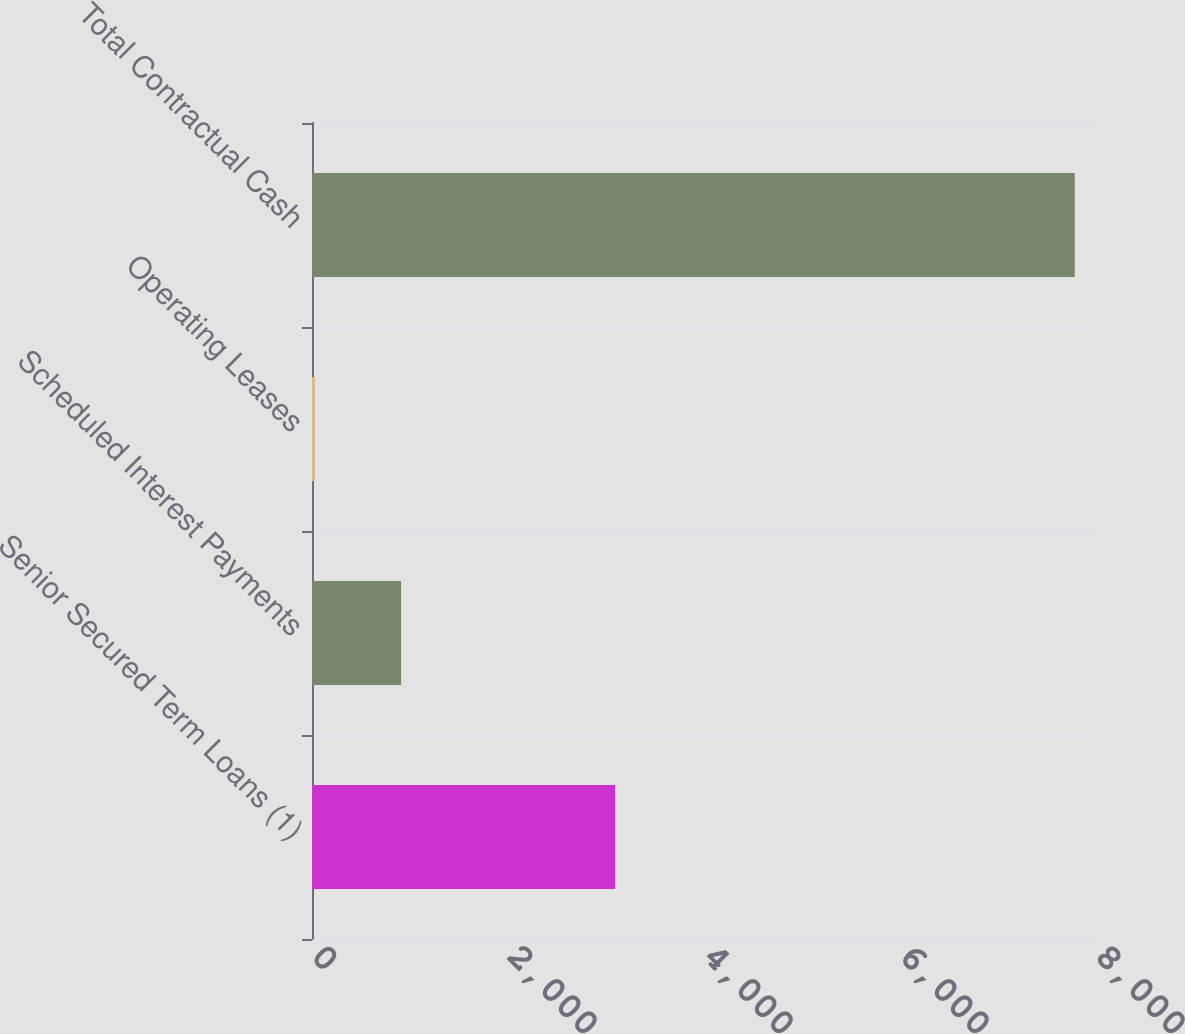Convert chart to OTSL. <chart><loc_0><loc_0><loc_500><loc_500><bar_chart><fcel>Senior Secured Term Loans (1)<fcel>Scheduled Interest Payments<fcel>Operating Leases<fcel>Total Contractual Cash<nl><fcel>3093.6<fcel>909.4<fcel>30.2<fcel>7783.2<nl></chart> 